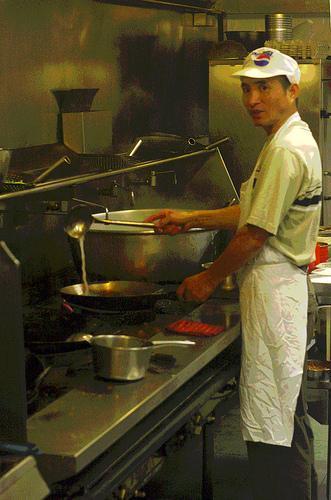How many people are in this picture?
Give a very brief answer. 1. 